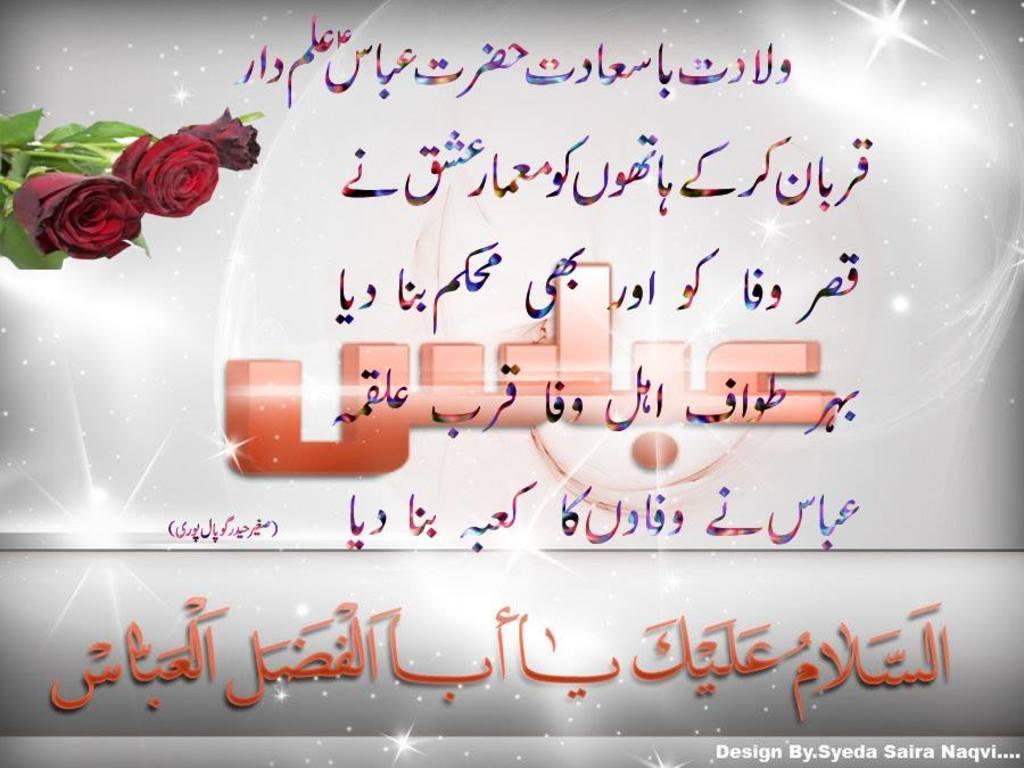In one or two sentences, can you explain what this image depicts? This image consists of a poster. It looks like an edited image. In which we can see the text and rose flowers. 